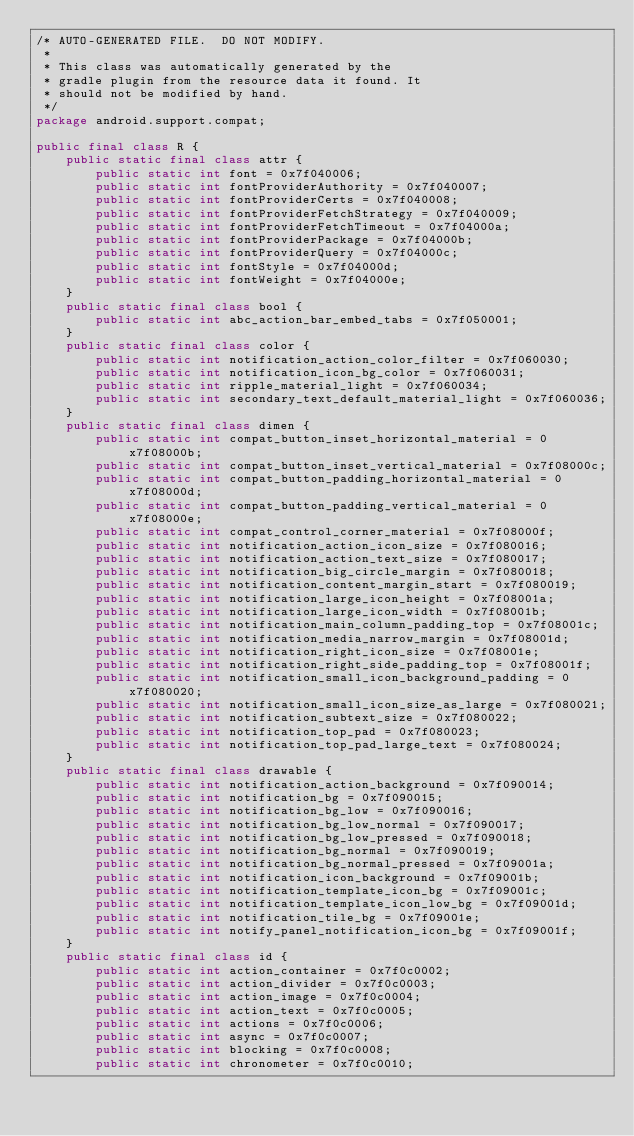Convert code to text. <code><loc_0><loc_0><loc_500><loc_500><_Java_>/* AUTO-GENERATED FILE.  DO NOT MODIFY.
 *
 * This class was automatically generated by the
 * gradle plugin from the resource data it found. It
 * should not be modified by hand.
 */
package android.support.compat;

public final class R {
    public static final class attr {
        public static int font = 0x7f040006;
        public static int fontProviderAuthority = 0x7f040007;
        public static int fontProviderCerts = 0x7f040008;
        public static int fontProviderFetchStrategy = 0x7f040009;
        public static int fontProviderFetchTimeout = 0x7f04000a;
        public static int fontProviderPackage = 0x7f04000b;
        public static int fontProviderQuery = 0x7f04000c;
        public static int fontStyle = 0x7f04000d;
        public static int fontWeight = 0x7f04000e;
    }
    public static final class bool {
        public static int abc_action_bar_embed_tabs = 0x7f050001;
    }
    public static final class color {
        public static int notification_action_color_filter = 0x7f060030;
        public static int notification_icon_bg_color = 0x7f060031;
        public static int ripple_material_light = 0x7f060034;
        public static int secondary_text_default_material_light = 0x7f060036;
    }
    public static final class dimen {
        public static int compat_button_inset_horizontal_material = 0x7f08000b;
        public static int compat_button_inset_vertical_material = 0x7f08000c;
        public static int compat_button_padding_horizontal_material = 0x7f08000d;
        public static int compat_button_padding_vertical_material = 0x7f08000e;
        public static int compat_control_corner_material = 0x7f08000f;
        public static int notification_action_icon_size = 0x7f080016;
        public static int notification_action_text_size = 0x7f080017;
        public static int notification_big_circle_margin = 0x7f080018;
        public static int notification_content_margin_start = 0x7f080019;
        public static int notification_large_icon_height = 0x7f08001a;
        public static int notification_large_icon_width = 0x7f08001b;
        public static int notification_main_column_padding_top = 0x7f08001c;
        public static int notification_media_narrow_margin = 0x7f08001d;
        public static int notification_right_icon_size = 0x7f08001e;
        public static int notification_right_side_padding_top = 0x7f08001f;
        public static int notification_small_icon_background_padding = 0x7f080020;
        public static int notification_small_icon_size_as_large = 0x7f080021;
        public static int notification_subtext_size = 0x7f080022;
        public static int notification_top_pad = 0x7f080023;
        public static int notification_top_pad_large_text = 0x7f080024;
    }
    public static final class drawable {
        public static int notification_action_background = 0x7f090014;
        public static int notification_bg = 0x7f090015;
        public static int notification_bg_low = 0x7f090016;
        public static int notification_bg_low_normal = 0x7f090017;
        public static int notification_bg_low_pressed = 0x7f090018;
        public static int notification_bg_normal = 0x7f090019;
        public static int notification_bg_normal_pressed = 0x7f09001a;
        public static int notification_icon_background = 0x7f09001b;
        public static int notification_template_icon_bg = 0x7f09001c;
        public static int notification_template_icon_low_bg = 0x7f09001d;
        public static int notification_tile_bg = 0x7f09001e;
        public static int notify_panel_notification_icon_bg = 0x7f09001f;
    }
    public static final class id {
        public static int action_container = 0x7f0c0002;
        public static int action_divider = 0x7f0c0003;
        public static int action_image = 0x7f0c0004;
        public static int action_text = 0x7f0c0005;
        public static int actions = 0x7f0c0006;
        public static int async = 0x7f0c0007;
        public static int blocking = 0x7f0c0008;
        public static int chronometer = 0x7f0c0010;</code> 